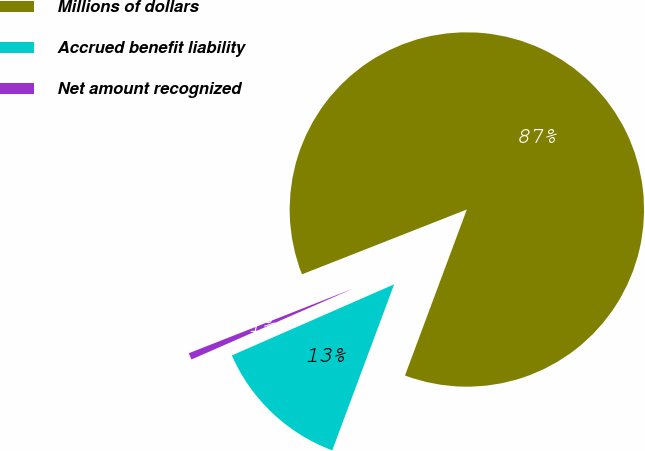Convert chart to OTSL. <chart><loc_0><loc_0><loc_500><loc_500><pie_chart><fcel>Millions of dollars<fcel>Accrued benefit liability<fcel>Net amount recognized<nl><fcel>86.65%<fcel>12.75%<fcel>0.61%<nl></chart> 